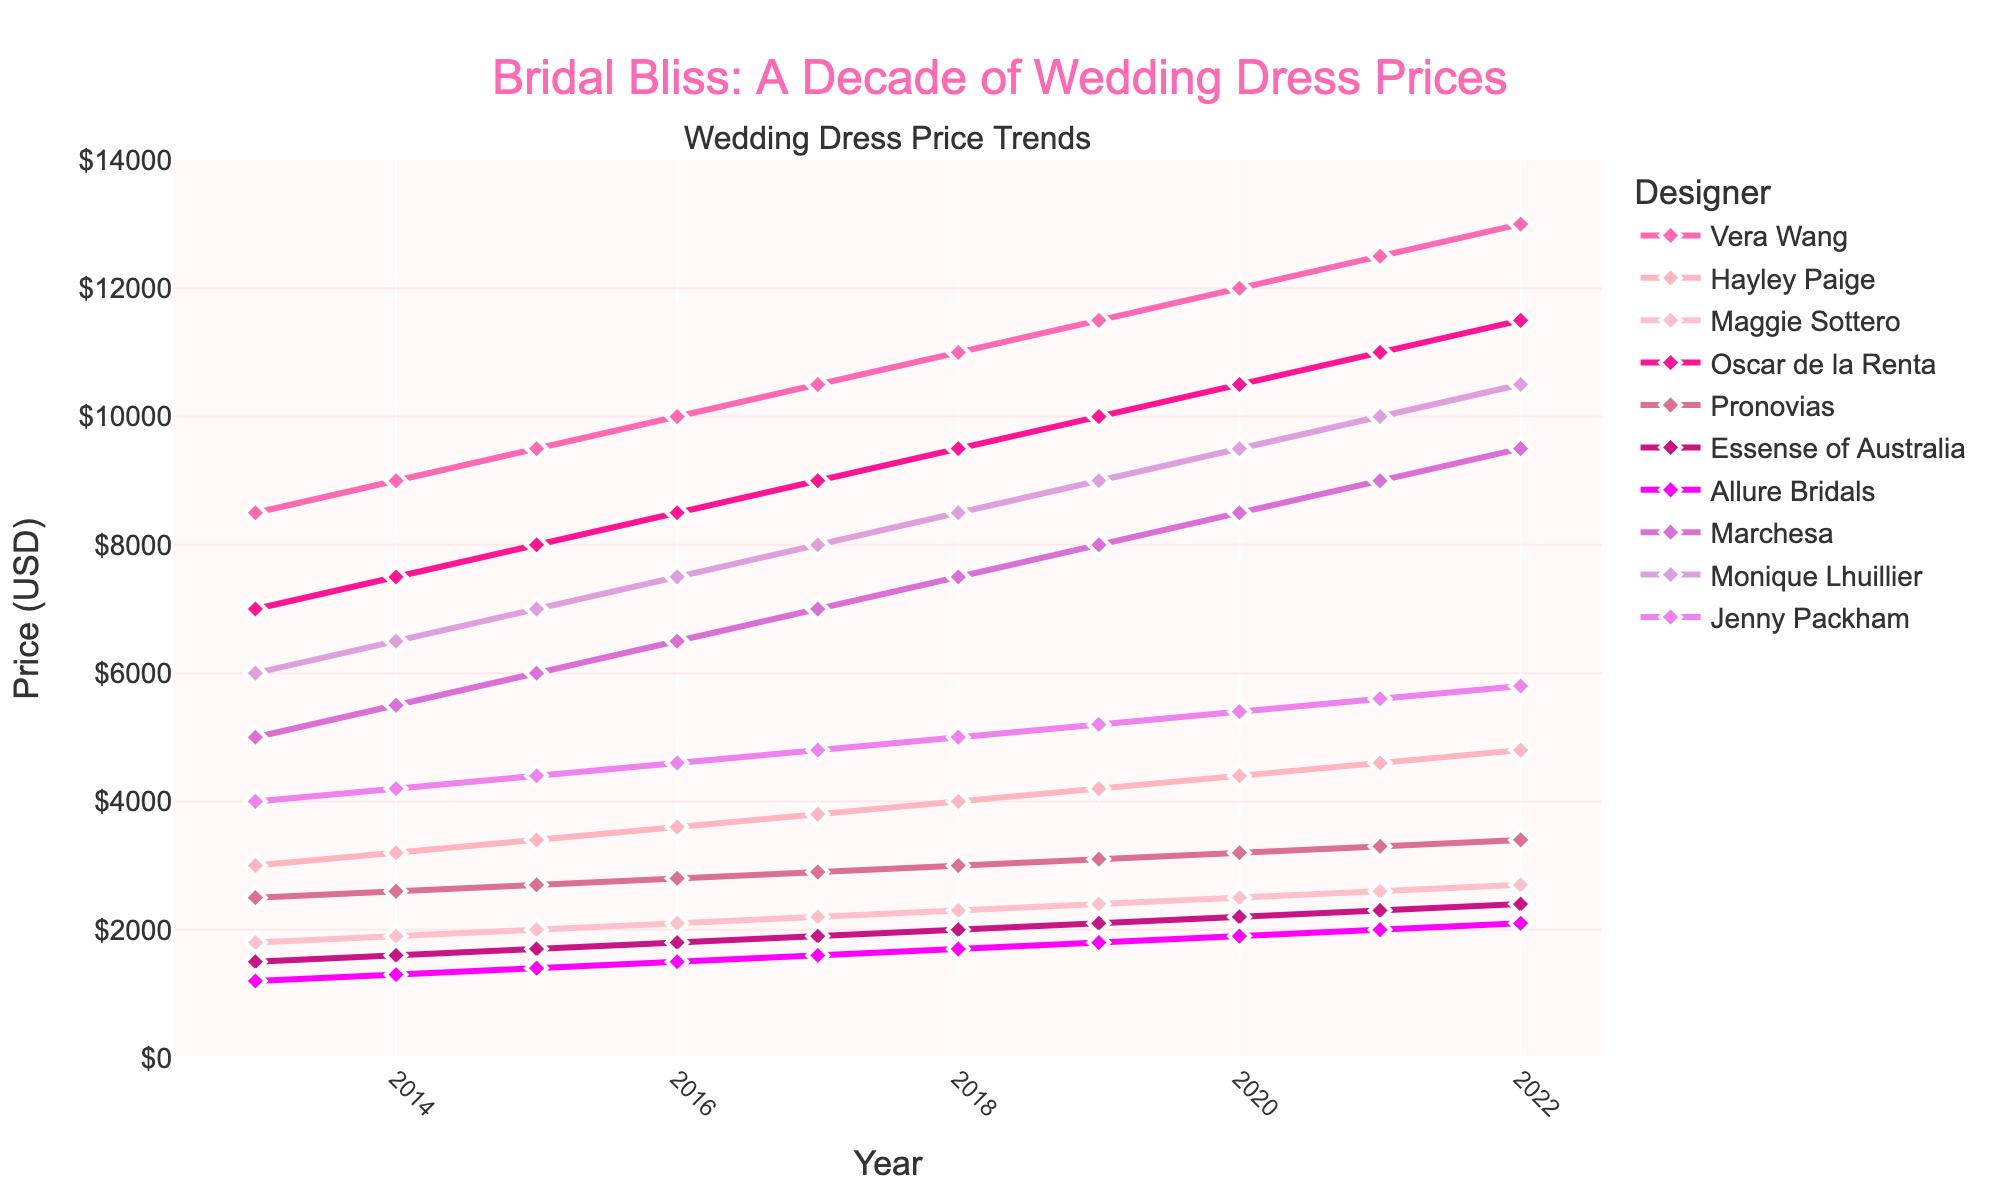What is the trend in the average cost of Vera Wang wedding dresses over the past decade? To identify the trend, trace the line representing Vera Wang from 2013 to 2022. The cost starts at $8,500 in 2013 and increases steadily each year, reaching $13,000 in 2022.
Answer: Increasing Which designer had the most expensive wedding dresses in 2013? Examine the lines at the year 2013 to find the highest starting point. Vera Wang has the highest value, starting at $8,500 in 2013.
Answer: Vera Wang By how much did the average cost of Monique Lhuillier wedding dresses increase from 2013 to 2022? Find the value for Monique Lhuillier in 2013 ($6,000) and in 2022 ($10,500). Subtract the 2013 value from the 2022 value: $10,500 - $6,000.
Answer: $4,500 Which designer had the least increase in the average cost of wedding dresses over the past decade? Calculate the difference between the 2022 and 2013 prices for each designer. Allure Bridals increased from $1,200 to $2,100 which is $900, the smallest increase.
Answer: Allure Bridals Between which two consecutive years did Hayley Paige have the highest increase in the average cost of wedding dresses? Look at the increments in the cost of Hayley Paige wedding dresses year by year, noting the differences: 2013-2014 ($200), 2014-2015 ($200), 2015-2016 ($200), 2016-2017 ($200), 2017-2018 ($200), 2018-2019 ($200), 2019-2020 ($200), 2020-2021 ($200), 2021-2022 ($200). Each increase is the same at $200.
Answer: 2013-2014 (or any two consecutive years) What's the average cost of Oscar de la Renta wedding dresses in 2015 and 2020 combined? First, find the values for Oscar de la Renta in 2015 ($8,000) and 2020 ($10,500). Combine them (sum up) and divide by 2 to find the average: ($8,000 + $10,500) / 2.
Answer: $9,250 Is the cost of wedding dresses from Jenny Packham ever higher than Monique Lhuillier from 2013 to 2022? Compare the lines representing Jenny Packham and Monique Lhuillier year by year. Jenny Packham's highest value in 2022 is $5,800, which is always lower than Monique Lhuillier's values, making it always less expensive.
Answer: No By what percentage did the average cost of Marchesa wedding dresses increase from 2013 to 2022? Find Marchesa's costs in 2013 ($5,000) and 2022 ($9,500). Use the percentage increase formula: [(9,500 - 5,000) / 5,000] * 100.
Answer: 90% Between Marchesa and Pronovias, which designer had a greater increase in price from 2013 to 2022, and by how much? Calculate the increase for Marchesa ($9,500 - $5,000 = $4,500) and Pronovias ($3,400 - $2,500 = $900). Compare the two increases: $4,500 for Marchesa is greater.
Answer: Marchesa, by $3,600 